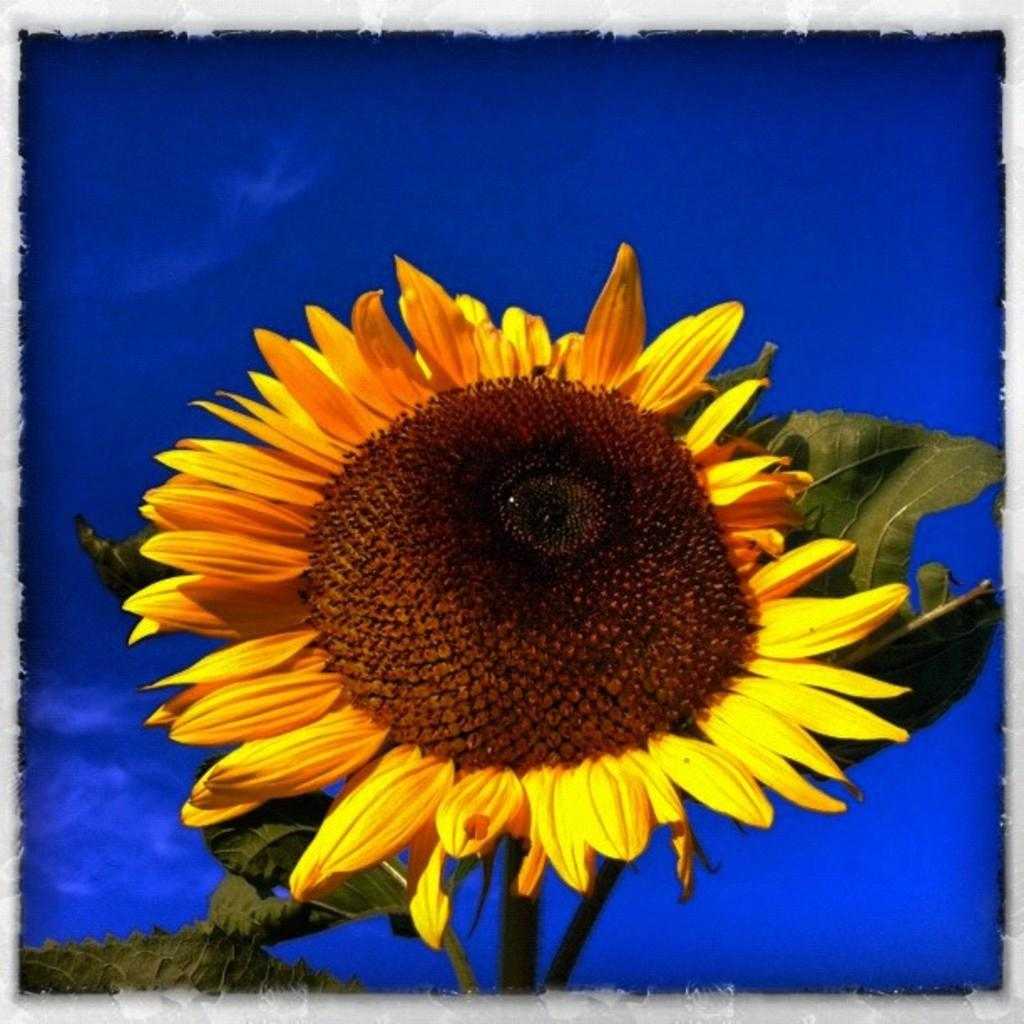What type of editing has been done to the image? The image is edited, but the specific type of editing is not mentioned in the facts. Where was the image taken? The image is taken outdoors. What is the main subject of the image? There is a plant with a sunflower in the middle of the image. What color dominates the background of the image? The background color is blue. Can you see a robin sitting on the chair in the image? There is no mention of a robin or a chair in the image, so we cannot answer this question. 